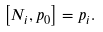Convert formula to latex. <formula><loc_0><loc_0><loc_500><loc_500>\left [ N _ { i } , p _ { 0 } \right ] = p _ { i } .</formula> 